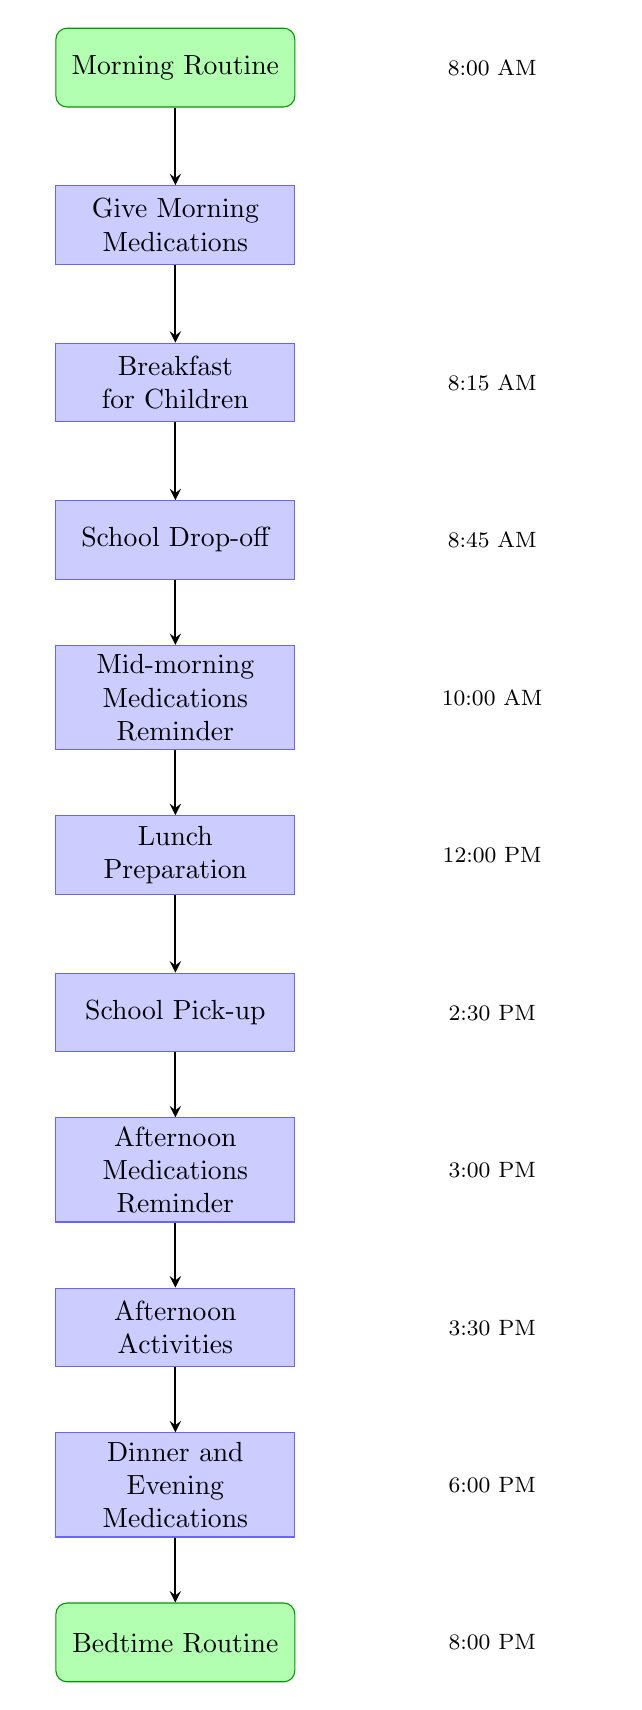What is the first activity in the morning routine? The first node in the diagram is labeled "Morning Routine," representing the beginning of the daily schedule.
Answer: Morning Routine At what time should the morning medications be given? The node "Give Morning Medications" indicates the time for this activity is 8:00 AM.
Answer: 8:00 AM How many processes (activities) are listed in the diagram? There are ten process nodes listed in the diagram, which describe various activities throughout the day.
Answer: 10 What follows after the "School Drop-off"? The node directly connected below "School Drop-off" is "Mid-morning Medications Reminder," which indicates the next activity in the flow.
Answer: Mid-morning Medications Reminder What time is the School Pick-up scheduled? The node "School Pick-up" shows the scheduled time as 2:30 PM.
Answer: 2:30 PM What is the last activity before the bedtime routine? The node preceding the "Bedtime Routine" is "Dinner and Evening Medications," which is the final activity before bed.
Answer: Dinner and Evening Medications At what time should the final medication check occur? According to the node "Bedtime Routine," the final medication check is scheduled for 8:00 PM.
Answer: 8:00 PM Which activity is scheduled at 3:00 PM? The node labeled "Afternoon Medications Reminder" corresponds to the activity scheduled at 3:00 PM.
Answer: Afternoon Medications Reminder How does the flow progress from lunch to school pickup? The flow from "Lunch Preparation" to "School Pick-up" is direct, signifying that after preparing lunch, the next task is to pick the children up from school.
Answer: School Pick-up 